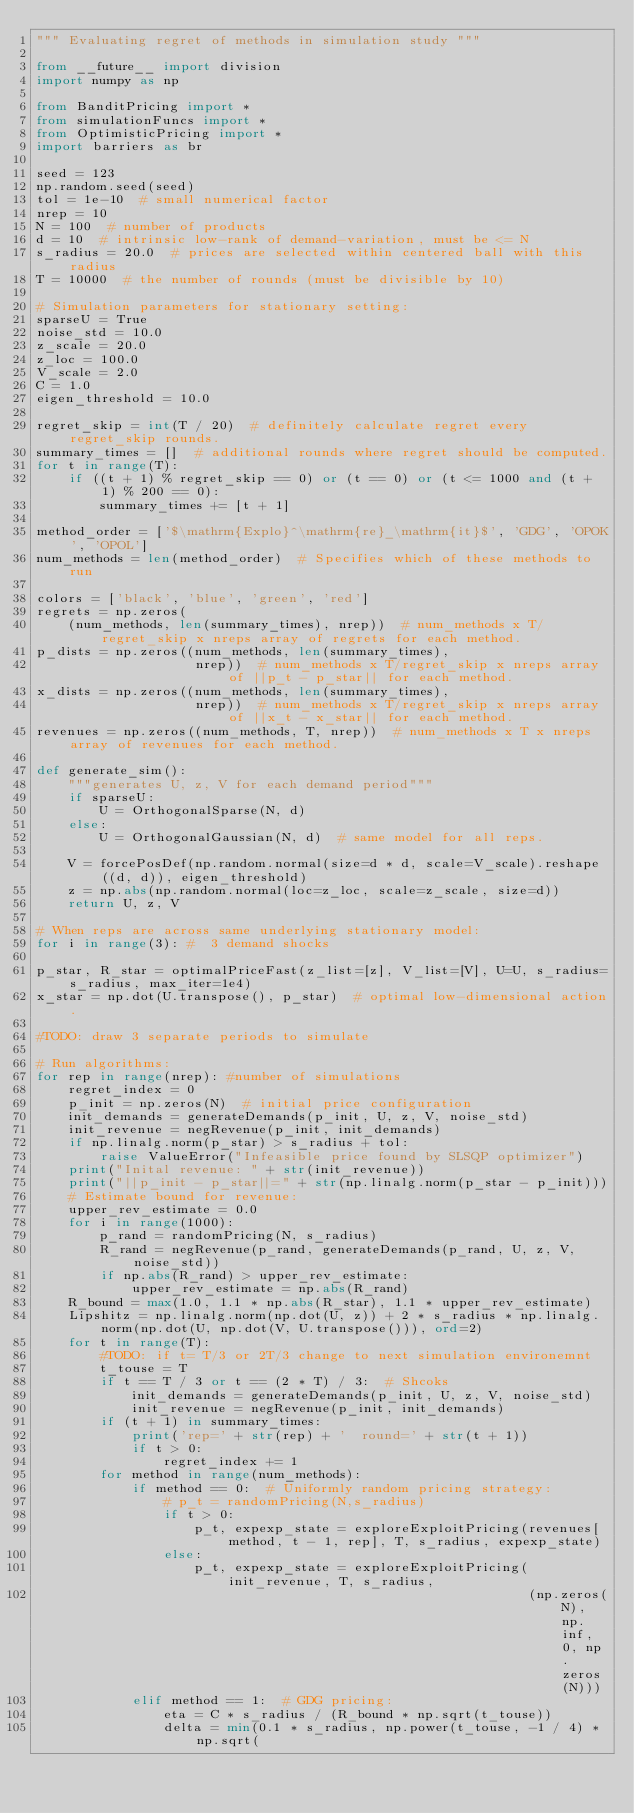Convert code to text. <code><loc_0><loc_0><loc_500><loc_500><_Python_>""" Evaluating regret of methods in simulation study """

from __future__ import division
import numpy as np

from BanditPricing import *
from simulationFuncs import *
from OptimisticPricing import *
import barriers as br

seed = 123
np.random.seed(seed)
tol = 1e-10  # small numerical factor
nrep = 10
N = 100  # number of products
d = 10  # intrinsic low-rank of demand-variation, must be <= N
s_radius = 20.0  # prices are selected within centered ball with this radius
T = 10000  # the number of rounds (must be divisible by 10)

# Simulation parameters for stationary setting:
sparseU = True
noise_std = 10.0
z_scale = 20.0
z_loc = 100.0
V_scale = 2.0
C = 1.0
eigen_threshold = 10.0

regret_skip = int(T / 20)  # definitely calculate regret every regret_skip rounds.
summary_times = []  # additional rounds where regret should be computed.
for t in range(T):
    if ((t + 1) % regret_skip == 0) or (t == 0) or (t <= 1000 and (t + 1) % 200 == 0):
        summary_times += [t + 1]

method_order = ['$\mathrm{Explo}^\mathrm{re}_\mathrm{it}$', 'GDG', 'OPOK', 'OPOL']
num_methods = len(method_order)  # Specifies which of these methods to run

colors = ['black', 'blue', 'green', 'red']
regrets = np.zeros(
    (num_methods, len(summary_times), nrep))  # num_methods x T/regret_skip x nreps array of regrets for each method.
p_dists = np.zeros((num_methods, len(summary_times),
                    nrep))  # num_methods x T/regret_skip x nreps array of ||p_t - p_star|| for each method.
x_dists = np.zeros((num_methods, len(summary_times),
                    nrep))  # num_methods x T/regret_skip x nreps array of ||x_t - x_star|| for each method.
revenues = np.zeros((num_methods, T, nrep))  # num_methods x T x nreps array of revenues for each method.

def generate_sim():
    """generates U, z, V for each demand period"""
    if sparseU:
        U = OrthogonalSparse(N, d)
    else:
        U = OrthogonalGaussian(N, d)  # same model for all reps.

    V = forcePosDef(np.random.normal(size=d * d, scale=V_scale).reshape((d, d)), eigen_threshold)
    z = np.abs(np.random.normal(loc=z_loc, scale=z_scale, size=d))
    return U, z, V

# When reps are across same underlying stationary model:
for i in range(3): #  3 demand shocks

p_star, R_star = optimalPriceFast(z_list=[z], V_list=[V], U=U, s_radius=s_radius, max_iter=1e4)
x_star = np.dot(U.transpose(), p_star)  # optimal low-dimensional action.

#TODO: draw 3 separate periods to simulate

# Run algorithms:
for rep in range(nrep): #number of simulations
    regret_index = 0
    p_init = np.zeros(N)  # initial price configuration
    init_demands = generateDemands(p_init, U, z, V, noise_std)
    init_revenue = negRevenue(p_init, init_demands)
    if np.linalg.norm(p_star) > s_radius + tol:
        raise ValueError("Infeasible price found by SLSQP optimizer")
    print("Inital revenue: " + str(init_revenue))
    print("||p_init - p_star||=" + str(np.linalg.norm(p_star - p_init)))
    # Estimate bound for revenue:
    upper_rev_estimate = 0.0
    for i in range(1000):
        p_rand = randomPricing(N, s_radius)
        R_rand = negRevenue(p_rand, generateDemands(p_rand, U, z, V, noise_std))
        if np.abs(R_rand) > upper_rev_estimate:
            upper_rev_estimate = np.abs(R_rand)
    R_bound = max(1.0, 1.1 * np.abs(R_star), 1.1 * upper_rev_estimate)
    Lipshitz = np.linalg.norm(np.dot(U, z)) + 2 * s_radius * np.linalg.norm(np.dot(U, np.dot(V, U.transpose())), ord=2)
    for t in range(T):
        #TODO: if t= T/3 or 2T/3 change to next simulation environemnt
        t_touse = T
        if t == T / 3 or t == (2 * T) / 3:  # Shcoks
            init_demands = generateDemands(p_init, U, z, V, noise_std)
            init_revenue = negRevenue(p_init, init_demands)
        if (t + 1) in summary_times:
            print('rep=' + str(rep) + '  round=' + str(t + 1))
            if t > 0:
                regret_index += 1
        for method in range(num_methods):
            if method == 0:  # Uniformly random pricing strategy:
                # p_t = randomPricing(N,s_radius)
                if t > 0:
                    p_t, expexp_state = exploreExploitPricing(revenues[method, t - 1, rep], T, s_radius, expexp_state)
                else:
                    p_t, expexp_state = exploreExploitPricing(init_revenue, T, s_radius,
                                                              (np.zeros(N), np.inf, 0, np.zeros(N)))
            elif method == 1:  # GDG pricing:
                eta = C * s_radius / (R_bound * np.sqrt(t_touse))
                delta = min(0.1 * s_radius, np.power(t_touse, -1 / 4) * np.sqrt(</code> 